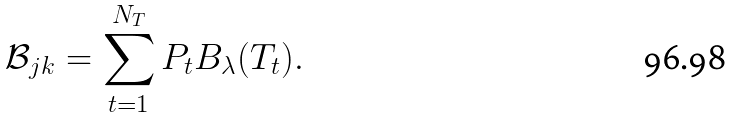Convert formula to latex. <formula><loc_0><loc_0><loc_500><loc_500>\mathcal { B } _ { j k } = \sum _ { t = 1 } ^ { N _ { T } } P _ { t } B _ { \lambda } ( T _ { t } ) .</formula> 